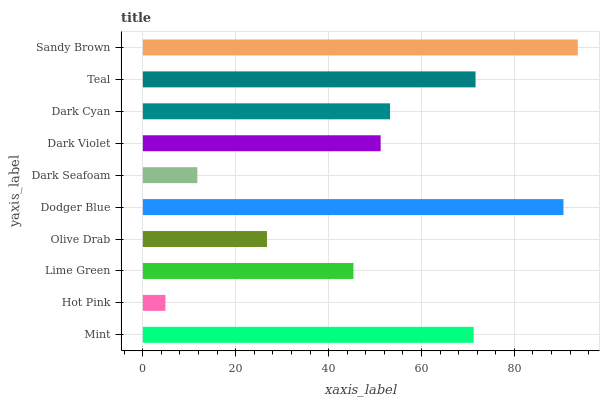Is Hot Pink the minimum?
Answer yes or no. Yes. Is Sandy Brown the maximum?
Answer yes or no. Yes. Is Lime Green the minimum?
Answer yes or no. No. Is Lime Green the maximum?
Answer yes or no. No. Is Lime Green greater than Hot Pink?
Answer yes or no. Yes. Is Hot Pink less than Lime Green?
Answer yes or no. Yes. Is Hot Pink greater than Lime Green?
Answer yes or no. No. Is Lime Green less than Hot Pink?
Answer yes or no. No. Is Dark Cyan the high median?
Answer yes or no. Yes. Is Dark Violet the low median?
Answer yes or no. Yes. Is Dodger Blue the high median?
Answer yes or no. No. Is Hot Pink the low median?
Answer yes or no. No. 